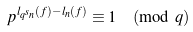<formula> <loc_0><loc_0><loc_500><loc_500>p ^ { l _ { q ^ { s } n } ( f ) - l _ { n } ( f ) } \equiv 1 \pmod { q }</formula> 